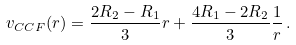<formula> <loc_0><loc_0><loc_500><loc_500>v _ { C C F } ( r ) = \frac { 2 R _ { 2 } - R _ { 1 } } { 3 } r + \frac { 4 R _ { 1 } - 2 R _ { 2 } } { 3 } \frac { 1 } { r } \, .</formula> 